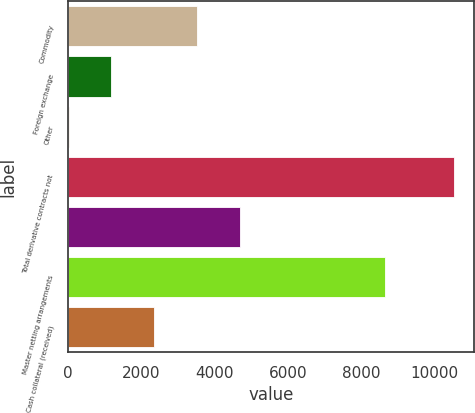Convert chart. <chart><loc_0><loc_0><loc_500><loc_500><bar_chart><fcel>Commodity<fcel>Foreign exchange<fcel>Other<fcel>Total derivative contracts not<fcel>Unnamed: 4<fcel>Master netting arrangements<fcel>Cash collateral (received)<nl><fcel>3519.5<fcel>1182.5<fcel>14<fcel>10533<fcel>4688<fcel>8653<fcel>2351<nl></chart> 